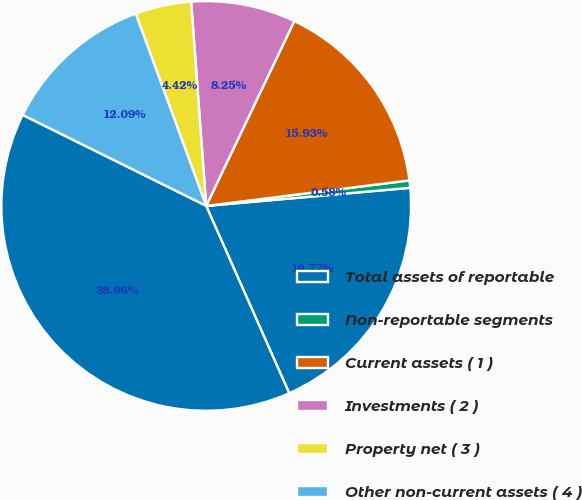Convert chart. <chart><loc_0><loc_0><loc_500><loc_500><pie_chart><fcel>Total assets of reportable<fcel>Non-reportable segments<fcel>Current assets ( 1 )<fcel>Investments ( 2 )<fcel>Property net ( 3 )<fcel>Other non-current assets ( 4 )<fcel>Total assets<nl><fcel>19.77%<fcel>0.58%<fcel>15.93%<fcel>8.25%<fcel>4.42%<fcel>12.09%<fcel>38.96%<nl></chart> 